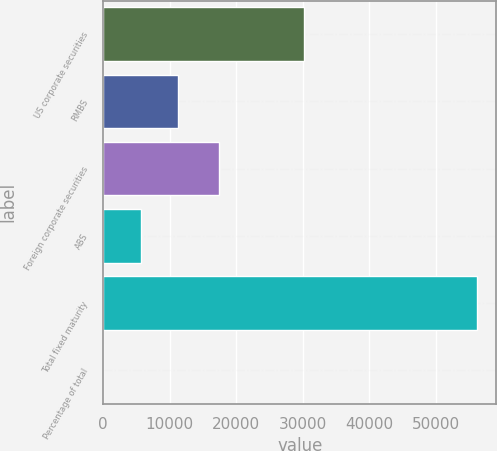Convert chart to OTSL. <chart><loc_0><loc_0><loc_500><loc_500><bar_chart><fcel>US corporate securities<fcel>RMBS<fcel>Foreign corporate securities<fcel>ABS<fcel>Total fixed maturity<fcel>Percentage of total<nl><fcel>30266<fcel>11280.8<fcel>17393<fcel>5652.73<fcel>56305<fcel>24.7<nl></chart> 